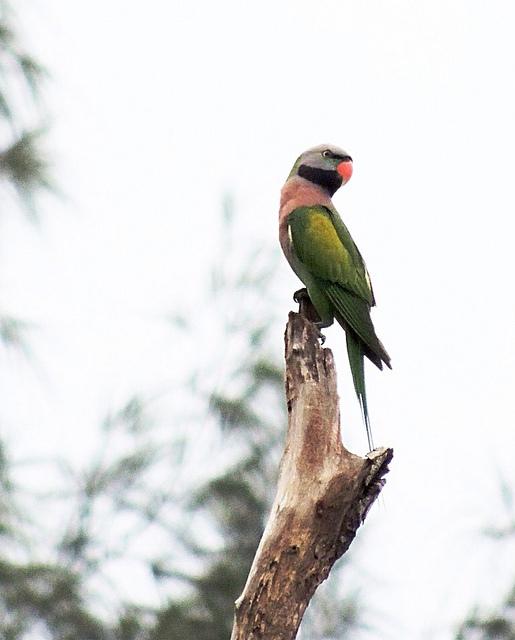Is the bird male?
Concise answer only. Yes. Is this birds beak long?
Answer briefly. No. What species of bird is on the tree stump?
Concise answer only. Parrot. 